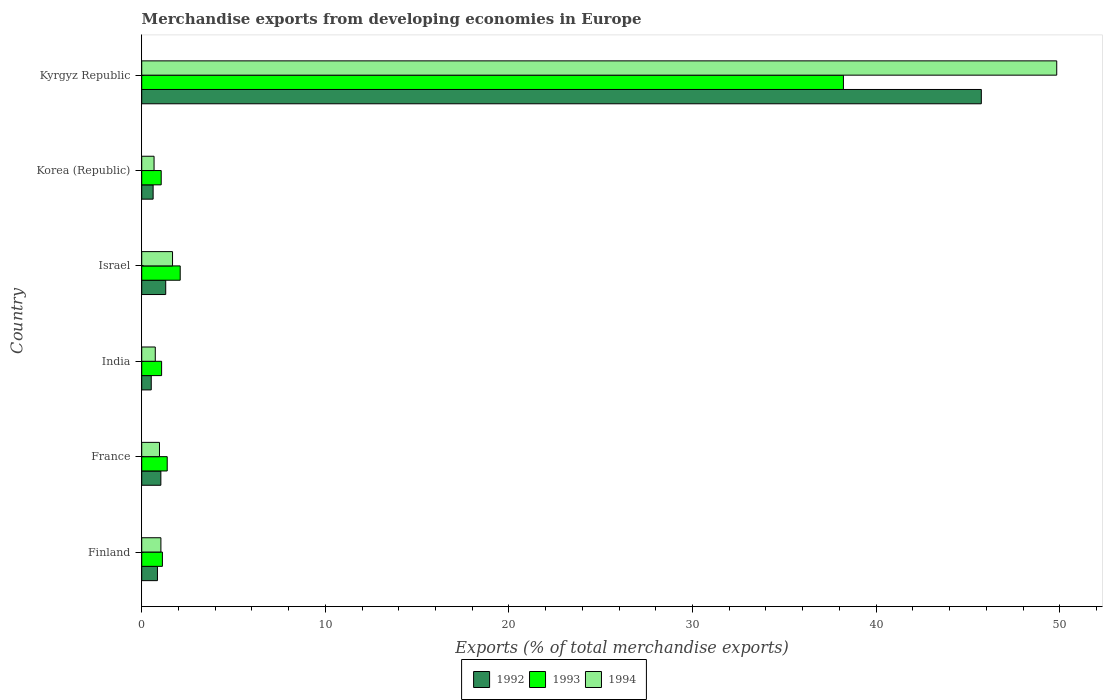How many groups of bars are there?
Ensure brevity in your answer.  6. Are the number of bars per tick equal to the number of legend labels?
Provide a short and direct response. Yes. How many bars are there on the 6th tick from the bottom?
Give a very brief answer. 3. What is the percentage of total merchandise exports in 1993 in Finland?
Your response must be concise. 1.13. Across all countries, what is the maximum percentage of total merchandise exports in 1993?
Give a very brief answer. 38.22. Across all countries, what is the minimum percentage of total merchandise exports in 1994?
Keep it short and to the point. 0.67. In which country was the percentage of total merchandise exports in 1993 maximum?
Make the answer very short. Kyrgyz Republic. What is the total percentage of total merchandise exports in 1994 in the graph?
Provide a succinct answer. 54.94. What is the difference between the percentage of total merchandise exports in 1994 in Israel and that in Korea (Republic)?
Provide a succinct answer. 1.01. What is the difference between the percentage of total merchandise exports in 1994 in Israel and the percentage of total merchandise exports in 1992 in India?
Give a very brief answer. 1.16. What is the average percentage of total merchandise exports in 1994 per country?
Offer a terse response. 9.16. What is the difference between the percentage of total merchandise exports in 1994 and percentage of total merchandise exports in 1993 in Finland?
Provide a succinct answer. -0.08. In how many countries, is the percentage of total merchandise exports in 1992 greater than 28 %?
Make the answer very short. 1. What is the ratio of the percentage of total merchandise exports in 1994 in France to that in Korea (Republic)?
Offer a very short reply. 1.44. What is the difference between the highest and the second highest percentage of total merchandise exports in 1994?
Offer a very short reply. 48.16. What is the difference between the highest and the lowest percentage of total merchandise exports in 1992?
Provide a short and direct response. 45.21. In how many countries, is the percentage of total merchandise exports in 1993 greater than the average percentage of total merchandise exports in 1993 taken over all countries?
Your response must be concise. 1. Is the sum of the percentage of total merchandise exports in 1992 in France and Israel greater than the maximum percentage of total merchandise exports in 1994 across all countries?
Keep it short and to the point. No. What does the 2nd bar from the bottom in Kyrgyz Republic represents?
Provide a succinct answer. 1993. Is it the case that in every country, the sum of the percentage of total merchandise exports in 1993 and percentage of total merchandise exports in 1994 is greater than the percentage of total merchandise exports in 1992?
Keep it short and to the point. Yes. How many bars are there?
Your answer should be compact. 18. What is the difference between two consecutive major ticks on the X-axis?
Give a very brief answer. 10. Does the graph contain any zero values?
Keep it short and to the point. No. Where does the legend appear in the graph?
Ensure brevity in your answer.  Bottom center. What is the title of the graph?
Provide a short and direct response. Merchandise exports from developing economies in Europe. Does "1986" appear as one of the legend labels in the graph?
Offer a terse response. No. What is the label or title of the X-axis?
Your response must be concise. Exports (% of total merchandise exports). What is the label or title of the Y-axis?
Your answer should be very brief. Country. What is the Exports (% of total merchandise exports) in 1992 in Finland?
Your response must be concise. 0.86. What is the Exports (% of total merchandise exports) of 1993 in Finland?
Provide a succinct answer. 1.13. What is the Exports (% of total merchandise exports) in 1994 in Finland?
Offer a terse response. 1.05. What is the Exports (% of total merchandise exports) in 1992 in France?
Give a very brief answer. 1.04. What is the Exports (% of total merchandise exports) in 1993 in France?
Make the answer very short. 1.39. What is the Exports (% of total merchandise exports) of 1994 in France?
Provide a succinct answer. 0.97. What is the Exports (% of total merchandise exports) in 1992 in India?
Give a very brief answer. 0.52. What is the Exports (% of total merchandise exports) in 1993 in India?
Your answer should be compact. 1.08. What is the Exports (% of total merchandise exports) of 1994 in India?
Provide a succinct answer. 0.74. What is the Exports (% of total merchandise exports) in 1992 in Israel?
Provide a short and direct response. 1.31. What is the Exports (% of total merchandise exports) of 1993 in Israel?
Offer a terse response. 2.1. What is the Exports (% of total merchandise exports) in 1994 in Israel?
Your response must be concise. 1.68. What is the Exports (% of total merchandise exports) of 1992 in Korea (Republic)?
Ensure brevity in your answer.  0.62. What is the Exports (% of total merchandise exports) in 1993 in Korea (Republic)?
Your answer should be compact. 1.06. What is the Exports (% of total merchandise exports) in 1994 in Korea (Republic)?
Make the answer very short. 0.67. What is the Exports (% of total merchandise exports) of 1992 in Kyrgyz Republic?
Give a very brief answer. 45.73. What is the Exports (% of total merchandise exports) in 1993 in Kyrgyz Republic?
Offer a terse response. 38.22. What is the Exports (% of total merchandise exports) of 1994 in Kyrgyz Republic?
Offer a very short reply. 49.84. Across all countries, what is the maximum Exports (% of total merchandise exports) in 1992?
Your answer should be very brief. 45.73. Across all countries, what is the maximum Exports (% of total merchandise exports) in 1993?
Ensure brevity in your answer.  38.22. Across all countries, what is the maximum Exports (% of total merchandise exports) in 1994?
Keep it short and to the point. 49.84. Across all countries, what is the minimum Exports (% of total merchandise exports) in 1992?
Give a very brief answer. 0.52. Across all countries, what is the minimum Exports (% of total merchandise exports) of 1993?
Keep it short and to the point. 1.06. Across all countries, what is the minimum Exports (% of total merchandise exports) in 1994?
Provide a short and direct response. 0.67. What is the total Exports (% of total merchandise exports) in 1992 in the graph?
Your response must be concise. 50.07. What is the total Exports (% of total merchandise exports) of 1993 in the graph?
Ensure brevity in your answer.  44.97. What is the total Exports (% of total merchandise exports) in 1994 in the graph?
Provide a succinct answer. 54.94. What is the difference between the Exports (% of total merchandise exports) of 1992 in Finland and that in France?
Your answer should be very brief. -0.19. What is the difference between the Exports (% of total merchandise exports) of 1993 in Finland and that in France?
Provide a short and direct response. -0.26. What is the difference between the Exports (% of total merchandise exports) in 1994 in Finland and that in France?
Offer a very short reply. 0.08. What is the difference between the Exports (% of total merchandise exports) of 1992 in Finland and that in India?
Offer a very short reply. 0.34. What is the difference between the Exports (% of total merchandise exports) in 1993 in Finland and that in India?
Your answer should be very brief. 0.04. What is the difference between the Exports (% of total merchandise exports) of 1994 in Finland and that in India?
Ensure brevity in your answer.  0.31. What is the difference between the Exports (% of total merchandise exports) of 1992 in Finland and that in Israel?
Keep it short and to the point. -0.45. What is the difference between the Exports (% of total merchandise exports) of 1993 in Finland and that in Israel?
Make the answer very short. -0.97. What is the difference between the Exports (% of total merchandise exports) in 1994 in Finland and that in Israel?
Provide a short and direct response. -0.63. What is the difference between the Exports (% of total merchandise exports) of 1992 in Finland and that in Korea (Republic)?
Provide a short and direct response. 0.24. What is the difference between the Exports (% of total merchandise exports) in 1993 in Finland and that in Korea (Republic)?
Offer a very short reply. 0.07. What is the difference between the Exports (% of total merchandise exports) in 1994 in Finland and that in Korea (Republic)?
Keep it short and to the point. 0.37. What is the difference between the Exports (% of total merchandise exports) of 1992 in Finland and that in Kyrgyz Republic?
Your answer should be very brief. -44.87. What is the difference between the Exports (% of total merchandise exports) of 1993 in Finland and that in Kyrgyz Republic?
Keep it short and to the point. -37.09. What is the difference between the Exports (% of total merchandise exports) in 1994 in Finland and that in Kyrgyz Republic?
Give a very brief answer. -48.79. What is the difference between the Exports (% of total merchandise exports) in 1992 in France and that in India?
Your answer should be compact. 0.52. What is the difference between the Exports (% of total merchandise exports) in 1993 in France and that in India?
Give a very brief answer. 0.31. What is the difference between the Exports (% of total merchandise exports) of 1994 in France and that in India?
Your answer should be compact. 0.23. What is the difference between the Exports (% of total merchandise exports) of 1992 in France and that in Israel?
Your response must be concise. -0.26. What is the difference between the Exports (% of total merchandise exports) of 1993 in France and that in Israel?
Your answer should be very brief. -0.71. What is the difference between the Exports (% of total merchandise exports) of 1994 in France and that in Israel?
Your answer should be very brief. -0.71. What is the difference between the Exports (% of total merchandise exports) in 1992 in France and that in Korea (Republic)?
Ensure brevity in your answer.  0.42. What is the difference between the Exports (% of total merchandise exports) in 1993 in France and that in Korea (Republic)?
Keep it short and to the point. 0.33. What is the difference between the Exports (% of total merchandise exports) of 1994 in France and that in Korea (Republic)?
Your response must be concise. 0.3. What is the difference between the Exports (% of total merchandise exports) of 1992 in France and that in Kyrgyz Republic?
Ensure brevity in your answer.  -44.69. What is the difference between the Exports (% of total merchandise exports) of 1993 in France and that in Kyrgyz Republic?
Offer a terse response. -36.83. What is the difference between the Exports (% of total merchandise exports) of 1994 in France and that in Kyrgyz Republic?
Ensure brevity in your answer.  -48.87. What is the difference between the Exports (% of total merchandise exports) of 1992 in India and that in Israel?
Provide a succinct answer. -0.79. What is the difference between the Exports (% of total merchandise exports) in 1993 in India and that in Israel?
Ensure brevity in your answer.  -1.01. What is the difference between the Exports (% of total merchandise exports) of 1994 in India and that in Israel?
Keep it short and to the point. -0.94. What is the difference between the Exports (% of total merchandise exports) in 1992 in India and that in Korea (Republic)?
Your answer should be very brief. -0.1. What is the difference between the Exports (% of total merchandise exports) of 1993 in India and that in Korea (Republic)?
Provide a succinct answer. 0.02. What is the difference between the Exports (% of total merchandise exports) of 1994 in India and that in Korea (Republic)?
Offer a very short reply. 0.07. What is the difference between the Exports (% of total merchandise exports) of 1992 in India and that in Kyrgyz Republic?
Give a very brief answer. -45.21. What is the difference between the Exports (% of total merchandise exports) in 1993 in India and that in Kyrgyz Republic?
Offer a terse response. -37.13. What is the difference between the Exports (% of total merchandise exports) in 1994 in India and that in Kyrgyz Republic?
Ensure brevity in your answer.  -49.1. What is the difference between the Exports (% of total merchandise exports) in 1992 in Israel and that in Korea (Republic)?
Keep it short and to the point. 0.69. What is the difference between the Exports (% of total merchandise exports) of 1993 in Israel and that in Korea (Republic)?
Offer a terse response. 1.03. What is the difference between the Exports (% of total merchandise exports) in 1994 in Israel and that in Korea (Republic)?
Offer a very short reply. 1.01. What is the difference between the Exports (% of total merchandise exports) of 1992 in Israel and that in Kyrgyz Republic?
Offer a terse response. -44.42. What is the difference between the Exports (% of total merchandise exports) in 1993 in Israel and that in Kyrgyz Republic?
Give a very brief answer. -36.12. What is the difference between the Exports (% of total merchandise exports) of 1994 in Israel and that in Kyrgyz Republic?
Keep it short and to the point. -48.16. What is the difference between the Exports (% of total merchandise exports) in 1992 in Korea (Republic) and that in Kyrgyz Republic?
Give a very brief answer. -45.11. What is the difference between the Exports (% of total merchandise exports) of 1993 in Korea (Republic) and that in Kyrgyz Republic?
Give a very brief answer. -37.16. What is the difference between the Exports (% of total merchandise exports) of 1994 in Korea (Republic) and that in Kyrgyz Republic?
Offer a terse response. -49.16. What is the difference between the Exports (% of total merchandise exports) of 1992 in Finland and the Exports (% of total merchandise exports) of 1993 in France?
Offer a very short reply. -0.53. What is the difference between the Exports (% of total merchandise exports) in 1992 in Finland and the Exports (% of total merchandise exports) in 1994 in France?
Provide a succinct answer. -0.11. What is the difference between the Exports (% of total merchandise exports) in 1993 in Finland and the Exports (% of total merchandise exports) in 1994 in France?
Provide a succinct answer. 0.16. What is the difference between the Exports (% of total merchandise exports) of 1992 in Finland and the Exports (% of total merchandise exports) of 1993 in India?
Your answer should be compact. -0.23. What is the difference between the Exports (% of total merchandise exports) of 1992 in Finland and the Exports (% of total merchandise exports) of 1994 in India?
Ensure brevity in your answer.  0.12. What is the difference between the Exports (% of total merchandise exports) in 1993 in Finland and the Exports (% of total merchandise exports) in 1994 in India?
Your answer should be very brief. 0.39. What is the difference between the Exports (% of total merchandise exports) of 1992 in Finland and the Exports (% of total merchandise exports) of 1993 in Israel?
Offer a very short reply. -1.24. What is the difference between the Exports (% of total merchandise exports) in 1992 in Finland and the Exports (% of total merchandise exports) in 1994 in Israel?
Ensure brevity in your answer.  -0.82. What is the difference between the Exports (% of total merchandise exports) in 1993 in Finland and the Exports (% of total merchandise exports) in 1994 in Israel?
Your answer should be compact. -0.55. What is the difference between the Exports (% of total merchandise exports) of 1992 in Finland and the Exports (% of total merchandise exports) of 1993 in Korea (Republic)?
Offer a very short reply. -0.2. What is the difference between the Exports (% of total merchandise exports) in 1992 in Finland and the Exports (% of total merchandise exports) in 1994 in Korea (Republic)?
Your answer should be very brief. 0.18. What is the difference between the Exports (% of total merchandise exports) of 1993 in Finland and the Exports (% of total merchandise exports) of 1994 in Korea (Republic)?
Your answer should be very brief. 0.45. What is the difference between the Exports (% of total merchandise exports) of 1992 in Finland and the Exports (% of total merchandise exports) of 1993 in Kyrgyz Republic?
Make the answer very short. -37.36. What is the difference between the Exports (% of total merchandise exports) of 1992 in Finland and the Exports (% of total merchandise exports) of 1994 in Kyrgyz Republic?
Your response must be concise. -48.98. What is the difference between the Exports (% of total merchandise exports) of 1993 in Finland and the Exports (% of total merchandise exports) of 1994 in Kyrgyz Republic?
Your answer should be very brief. -48.71. What is the difference between the Exports (% of total merchandise exports) of 1992 in France and the Exports (% of total merchandise exports) of 1993 in India?
Provide a succinct answer. -0.04. What is the difference between the Exports (% of total merchandise exports) of 1992 in France and the Exports (% of total merchandise exports) of 1994 in India?
Make the answer very short. 0.3. What is the difference between the Exports (% of total merchandise exports) in 1993 in France and the Exports (% of total merchandise exports) in 1994 in India?
Keep it short and to the point. 0.65. What is the difference between the Exports (% of total merchandise exports) in 1992 in France and the Exports (% of total merchandise exports) in 1993 in Israel?
Provide a short and direct response. -1.05. What is the difference between the Exports (% of total merchandise exports) of 1992 in France and the Exports (% of total merchandise exports) of 1994 in Israel?
Ensure brevity in your answer.  -0.64. What is the difference between the Exports (% of total merchandise exports) in 1993 in France and the Exports (% of total merchandise exports) in 1994 in Israel?
Provide a short and direct response. -0.29. What is the difference between the Exports (% of total merchandise exports) of 1992 in France and the Exports (% of total merchandise exports) of 1993 in Korea (Republic)?
Ensure brevity in your answer.  -0.02. What is the difference between the Exports (% of total merchandise exports) of 1992 in France and the Exports (% of total merchandise exports) of 1994 in Korea (Republic)?
Offer a terse response. 0.37. What is the difference between the Exports (% of total merchandise exports) in 1993 in France and the Exports (% of total merchandise exports) in 1994 in Korea (Republic)?
Ensure brevity in your answer.  0.72. What is the difference between the Exports (% of total merchandise exports) in 1992 in France and the Exports (% of total merchandise exports) in 1993 in Kyrgyz Republic?
Make the answer very short. -37.18. What is the difference between the Exports (% of total merchandise exports) of 1992 in France and the Exports (% of total merchandise exports) of 1994 in Kyrgyz Republic?
Make the answer very short. -48.79. What is the difference between the Exports (% of total merchandise exports) in 1993 in France and the Exports (% of total merchandise exports) in 1994 in Kyrgyz Republic?
Provide a succinct answer. -48.45. What is the difference between the Exports (% of total merchandise exports) in 1992 in India and the Exports (% of total merchandise exports) in 1993 in Israel?
Make the answer very short. -1.58. What is the difference between the Exports (% of total merchandise exports) of 1992 in India and the Exports (% of total merchandise exports) of 1994 in Israel?
Keep it short and to the point. -1.16. What is the difference between the Exports (% of total merchandise exports) of 1993 in India and the Exports (% of total merchandise exports) of 1994 in Israel?
Ensure brevity in your answer.  -0.59. What is the difference between the Exports (% of total merchandise exports) of 1992 in India and the Exports (% of total merchandise exports) of 1993 in Korea (Republic)?
Provide a succinct answer. -0.54. What is the difference between the Exports (% of total merchandise exports) of 1992 in India and the Exports (% of total merchandise exports) of 1994 in Korea (Republic)?
Your response must be concise. -0.15. What is the difference between the Exports (% of total merchandise exports) of 1993 in India and the Exports (% of total merchandise exports) of 1994 in Korea (Republic)?
Provide a succinct answer. 0.41. What is the difference between the Exports (% of total merchandise exports) in 1992 in India and the Exports (% of total merchandise exports) in 1993 in Kyrgyz Republic?
Make the answer very short. -37.7. What is the difference between the Exports (% of total merchandise exports) in 1992 in India and the Exports (% of total merchandise exports) in 1994 in Kyrgyz Republic?
Your response must be concise. -49.32. What is the difference between the Exports (% of total merchandise exports) of 1993 in India and the Exports (% of total merchandise exports) of 1994 in Kyrgyz Republic?
Your response must be concise. -48.75. What is the difference between the Exports (% of total merchandise exports) of 1992 in Israel and the Exports (% of total merchandise exports) of 1993 in Korea (Republic)?
Your response must be concise. 0.25. What is the difference between the Exports (% of total merchandise exports) of 1992 in Israel and the Exports (% of total merchandise exports) of 1994 in Korea (Republic)?
Keep it short and to the point. 0.63. What is the difference between the Exports (% of total merchandise exports) in 1993 in Israel and the Exports (% of total merchandise exports) in 1994 in Korea (Republic)?
Your response must be concise. 1.42. What is the difference between the Exports (% of total merchandise exports) in 1992 in Israel and the Exports (% of total merchandise exports) in 1993 in Kyrgyz Republic?
Keep it short and to the point. -36.91. What is the difference between the Exports (% of total merchandise exports) of 1992 in Israel and the Exports (% of total merchandise exports) of 1994 in Kyrgyz Republic?
Ensure brevity in your answer.  -48.53. What is the difference between the Exports (% of total merchandise exports) in 1993 in Israel and the Exports (% of total merchandise exports) in 1994 in Kyrgyz Republic?
Provide a succinct answer. -47.74. What is the difference between the Exports (% of total merchandise exports) of 1992 in Korea (Republic) and the Exports (% of total merchandise exports) of 1993 in Kyrgyz Republic?
Provide a short and direct response. -37.6. What is the difference between the Exports (% of total merchandise exports) in 1992 in Korea (Republic) and the Exports (% of total merchandise exports) in 1994 in Kyrgyz Republic?
Your answer should be compact. -49.22. What is the difference between the Exports (% of total merchandise exports) of 1993 in Korea (Republic) and the Exports (% of total merchandise exports) of 1994 in Kyrgyz Republic?
Provide a succinct answer. -48.77. What is the average Exports (% of total merchandise exports) of 1992 per country?
Make the answer very short. 8.35. What is the average Exports (% of total merchandise exports) of 1993 per country?
Provide a succinct answer. 7.5. What is the average Exports (% of total merchandise exports) in 1994 per country?
Your answer should be very brief. 9.16. What is the difference between the Exports (% of total merchandise exports) of 1992 and Exports (% of total merchandise exports) of 1993 in Finland?
Offer a very short reply. -0.27. What is the difference between the Exports (% of total merchandise exports) of 1992 and Exports (% of total merchandise exports) of 1994 in Finland?
Provide a succinct answer. -0.19. What is the difference between the Exports (% of total merchandise exports) of 1993 and Exports (% of total merchandise exports) of 1994 in Finland?
Offer a very short reply. 0.08. What is the difference between the Exports (% of total merchandise exports) in 1992 and Exports (% of total merchandise exports) in 1993 in France?
Your response must be concise. -0.35. What is the difference between the Exports (% of total merchandise exports) in 1992 and Exports (% of total merchandise exports) in 1994 in France?
Offer a terse response. 0.07. What is the difference between the Exports (% of total merchandise exports) of 1993 and Exports (% of total merchandise exports) of 1994 in France?
Keep it short and to the point. 0.42. What is the difference between the Exports (% of total merchandise exports) of 1992 and Exports (% of total merchandise exports) of 1993 in India?
Give a very brief answer. -0.56. What is the difference between the Exports (% of total merchandise exports) of 1992 and Exports (% of total merchandise exports) of 1994 in India?
Provide a short and direct response. -0.22. What is the difference between the Exports (% of total merchandise exports) of 1993 and Exports (% of total merchandise exports) of 1994 in India?
Ensure brevity in your answer.  0.34. What is the difference between the Exports (% of total merchandise exports) in 1992 and Exports (% of total merchandise exports) in 1993 in Israel?
Ensure brevity in your answer.  -0.79. What is the difference between the Exports (% of total merchandise exports) in 1992 and Exports (% of total merchandise exports) in 1994 in Israel?
Provide a short and direct response. -0.37. What is the difference between the Exports (% of total merchandise exports) in 1993 and Exports (% of total merchandise exports) in 1994 in Israel?
Your answer should be compact. 0.42. What is the difference between the Exports (% of total merchandise exports) in 1992 and Exports (% of total merchandise exports) in 1993 in Korea (Republic)?
Your answer should be very brief. -0.44. What is the difference between the Exports (% of total merchandise exports) of 1992 and Exports (% of total merchandise exports) of 1994 in Korea (Republic)?
Provide a succinct answer. -0.05. What is the difference between the Exports (% of total merchandise exports) of 1993 and Exports (% of total merchandise exports) of 1994 in Korea (Republic)?
Your answer should be very brief. 0.39. What is the difference between the Exports (% of total merchandise exports) of 1992 and Exports (% of total merchandise exports) of 1993 in Kyrgyz Republic?
Your response must be concise. 7.51. What is the difference between the Exports (% of total merchandise exports) in 1992 and Exports (% of total merchandise exports) in 1994 in Kyrgyz Republic?
Your response must be concise. -4.11. What is the difference between the Exports (% of total merchandise exports) of 1993 and Exports (% of total merchandise exports) of 1994 in Kyrgyz Republic?
Your response must be concise. -11.62. What is the ratio of the Exports (% of total merchandise exports) in 1992 in Finland to that in France?
Offer a terse response. 0.82. What is the ratio of the Exports (% of total merchandise exports) in 1993 in Finland to that in France?
Give a very brief answer. 0.81. What is the ratio of the Exports (% of total merchandise exports) in 1994 in Finland to that in France?
Provide a short and direct response. 1.08. What is the ratio of the Exports (% of total merchandise exports) in 1992 in Finland to that in India?
Provide a succinct answer. 1.65. What is the ratio of the Exports (% of total merchandise exports) of 1993 in Finland to that in India?
Keep it short and to the point. 1.04. What is the ratio of the Exports (% of total merchandise exports) in 1994 in Finland to that in India?
Offer a very short reply. 1.41. What is the ratio of the Exports (% of total merchandise exports) of 1992 in Finland to that in Israel?
Offer a terse response. 0.66. What is the ratio of the Exports (% of total merchandise exports) in 1993 in Finland to that in Israel?
Provide a short and direct response. 0.54. What is the ratio of the Exports (% of total merchandise exports) in 1994 in Finland to that in Israel?
Make the answer very short. 0.62. What is the ratio of the Exports (% of total merchandise exports) in 1992 in Finland to that in Korea (Republic)?
Ensure brevity in your answer.  1.38. What is the ratio of the Exports (% of total merchandise exports) of 1993 in Finland to that in Korea (Republic)?
Offer a very short reply. 1.06. What is the ratio of the Exports (% of total merchandise exports) in 1994 in Finland to that in Korea (Republic)?
Provide a succinct answer. 1.55. What is the ratio of the Exports (% of total merchandise exports) in 1992 in Finland to that in Kyrgyz Republic?
Offer a very short reply. 0.02. What is the ratio of the Exports (% of total merchandise exports) in 1993 in Finland to that in Kyrgyz Republic?
Your answer should be compact. 0.03. What is the ratio of the Exports (% of total merchandise exports) in 1994 in Finland to that in Kyrgyz Republic?
Your answer should be very brief. 0.02. What is the ratio of the Exports (% of total merchandise exports) of 1992 in France to that in India?
Keep it short and to the point. 2.01. What is the ratio of the Exports (% of total merchandise exports) of 1993 in France to that in India?
Your response must be concise. 1.28. What is the ratio of the Exports (% of total merchandise exports) in 1994 in France to that in India?
Offer a terse response. 1.31. What is the ratio of the Exports (% of total merchandise exports) of 1992 in France to that in Israel?
Your response must be concise. 0.8. What is the ratio of the Exports (% of total merchandise exports) in 1993 in France to that in Israel?
Make the answer very short. 0.66. What is the ratio of the Exports (% of total merchandise exports) of 1994 in France to that in Israel?
Your answer should be compact. 0.58. What is the ratio of the Exports (% of total merchandise exports) in 1992 in France to that in Korea (Republic)?
Your response must be concise. 1.68. What is the ratio of the Exports (% of total merchandise exports) of 1993 in France to that in Korea (Republic)?
Give a very brief answer. 1.31. What is the ratio of the Exports (% of total merchandise exports) of 1994 in France to that in Korea (Republic)?
Your response must be concise. 1.44. What is the ratio of the Exports (% of total merchandise exports) in 1992 in France to that in Kyrgyz Republic?
Offer a terse response. 0.02. What is the ratio of the Exports (% of total merchandise exports) of 1993 in France to that in Kyrgyz Republic?
Provide a short and direct response. 0.04. What is the ratio of the Exports (% of total merchandise exports) in 1994 in France to that in Kyrgyz Republic?
Offer a terse response. 0.02. What is the ratio of the Exports (% of total merchandise exports) in 1992 in India to that in Israel?
Keep it short and to the point. 0.4. What is the ratio of the Exports (% of total merchandise exports) of 1993 in India to that in Israel?
Your response must be concise. 0.52. What is the ratio of the Exports (% of total merchandise exports) in 1994 in India to that in Israel?
Your answer should be compact. 0.44. What is the ratio of the Exports (% of total merchandise exports) in 1992 in India to that in Korea (Republic)?
Your answer should be compact. 0.84. What is the ratio of the Exports (% of total merchandise exports) of 1993 in India to that in Korea (Republic)?
Keep it short and to the point. 1.02. What is the ratio of the Exports (% of total merchandise exports) of 1994 in India to that in Korea (Republic)?
Offer a terse response. 1.1. What is the ratio of the Exports (% of total merchandise exports) of 1992 in India to that in Kyrgyz Republic?
Keep it short and to the point. 0.01. What is the ratio of the Exports (% of total merchandise exports) in 1993 in India to that in Kyrgyz Republic?
Give a very brief answer. 0.03. What is the ratio of the Exports (% of total merchandise exports) in 1994 in India to that in Kyrgyz Republic?
Keep it short and to the point. 0.01. What is the ratio of the Exports (% of total merchandise exports) of 1992 in Israel to that in Korea (Republic)?
Your answer should be compact. 2.11. What is the ratio of the Exports (% of total merchandise exports) in 1993 in Israel to that in Korea (Republic)?
Make the answer very short. 1.97. What is the ratio of the Exports (% of total merchandise exports) of 1994 in Israel to that in Korea (Republic)?
Offer a terse response. 2.49. What is the ratio of the Exports (% of total merchandise exports) of 1992 in Israel to that in Kyrgyz Republic?
Make the answer very short. 0.03. What is the ratio of the Exports (% of total merchandise exports) in 1993 in Israel to that in Kyrgyz Republic?
Offer a terse response. 0.05. What is the ratio of the Exports (% of total merchandise exports) in 1994 in Israel to that in Kyrgyz Republic?
Your answer should be compact. 0.03. What is the ratio of the Exports (% of total merchandise exports) of 1992 in Korea (Republic) to that in Kyrgyz Republic?
Make the answer very short. 0.01. What is the ratio of the Exports (% of total merchandise exports) in 1993 in Korea (Republic) to that in Kyrgyz Republic?
Provide a succinct answer. 0.03. What is the ratio of the Exports (% of total merchandise exports) of 1994 in Korea (Republic) to that in Kyrgyz Republic?
Ensure brevity in your answer.  0.01. What is the difference between the highest and the second highest Exports (% of total merchandise exports) of 1992?
Your response must be concise. 44.42. What is the difference between the highest and the second highest Exports (% of total merchandise exports) of 1993?
Offer a very short reply. 36.12. What is the difference between the highest and the second highest Exports (% of total merchandise exports) in 1994?
Give a very brief answer. 48.16. What is the difference between the highest and the lowest Exports (% of total merchandise exports) of 1992?
Your answer should be compact. 45.21. What is the difference between the highest and the lowest Exports (% of total merchandise exports) of 1993?
Offer a terse response. 37.16. What is the difference between the highest and the lowest Exports (% of total merchandise exports) of 1994?
Ensure brevity in your answer.  49.16. 